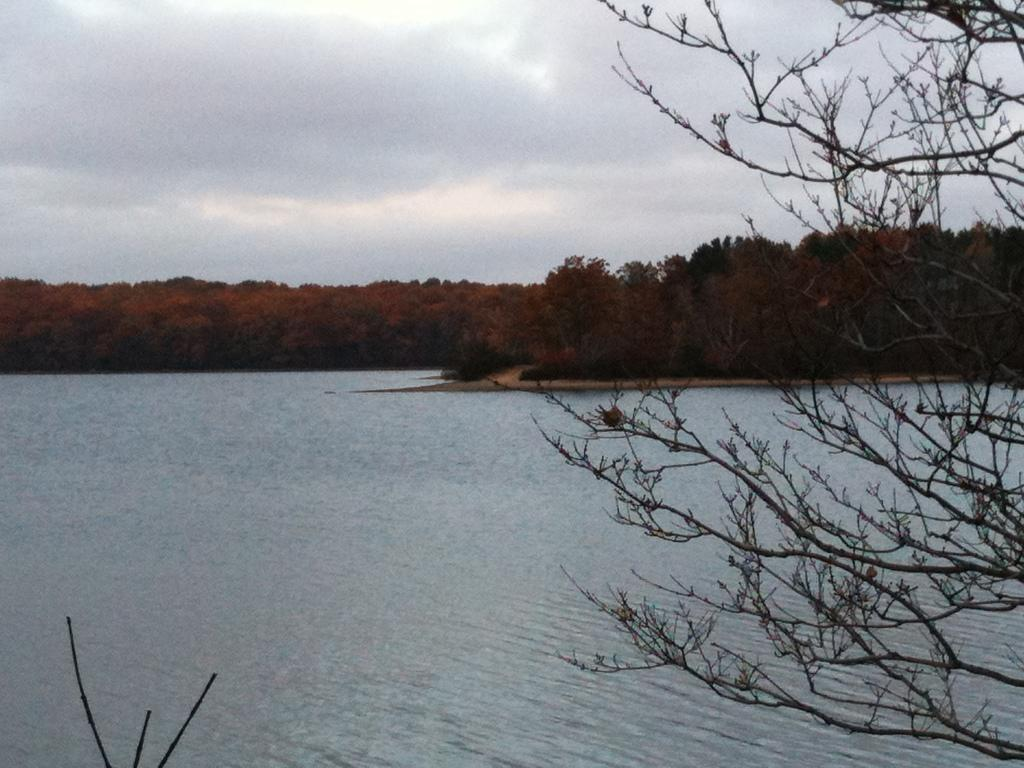What type of natural feature is at the bottom of the image? There is a river at the bottom of the image. What can be seen in the foreground of the image? There are trees in the foreground of the image. What can be seen in the background of the image? There are trees in the background of the image. What is visible at the top of the image? The sky is visible at the top of the image. Can you hear the thunder in the image? There is no sound present in the image, so it is not possible to hear thunder. What type of kitty can be seen playing with a rake in the image? There is no kitty or rake present in the image, and therefore no such activity can be observed. 